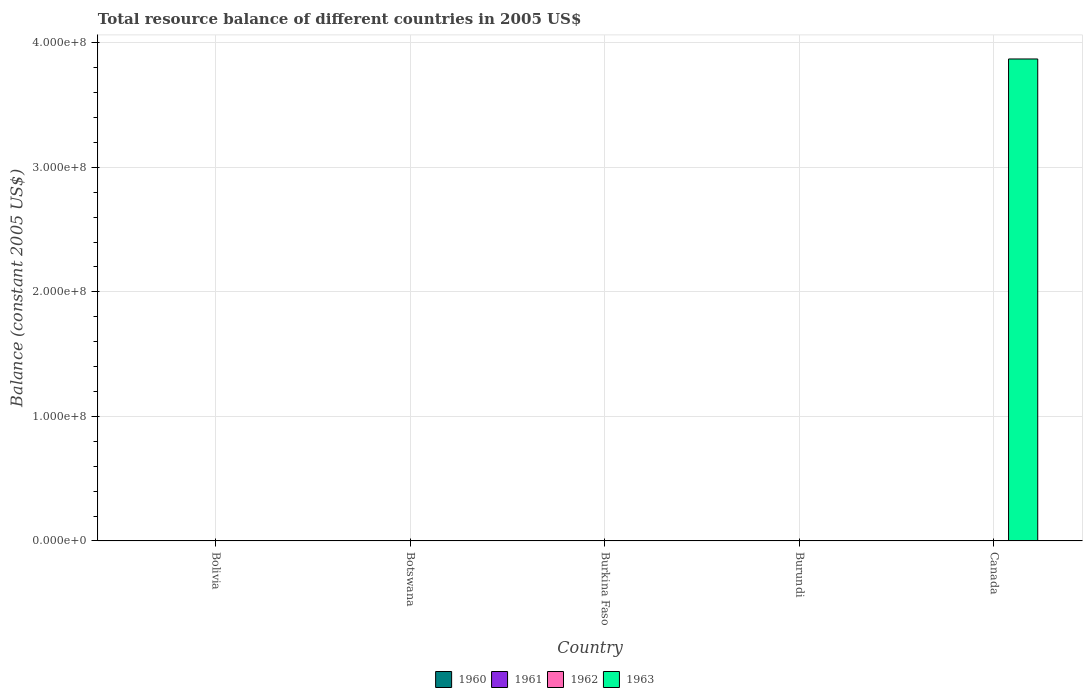Are the number of bars per tick equal to the number of legend labels?
Provide a succinct answer. No. How many bars are there on the 3rd tick from the left?
Give a very brief answer. 0. How many bars are there on the 3rd tick from the right?
Ensure brevity in your answer.  0. In how many cases, is the number of bars for a given country not equal to the number of legend labels?
Keep it short and to the point. 5. What is the total total resource balance in 1963 in the graph?
Your answer should be very brief. 3.87e+08. What is the average total resource balance in 1963 per country?
Ensure brevity in your answer.  7.74e+07. What is the difference between the highest and the lowest total resource balance in 1963?
Your response must be concise. 3.87e+08. In how many countries, is the total resource balance in 1963 greater than the average total resource balance in 1963 taken over all countries?
Offer a terse response. 1. Is it the case that in every country, the sum of the total resource balance in 1962 and total resource balance in 1961 is greater than the sum of total resource balance in 1963 and total resource balance in 1960?
Offer a terse response. No. Are all the bars in the graph horizontal?
Make the answer very short. No. What is the difference between two consecutive major ticks on the Y-axis?
Offer a very short reply. 1.00e+08. Does the graph contain grids?
Provide a succinct answer. Yes. Where does the legend appear in the graph?
Your answer should be compact. Bottom center. How are the legend labels stacked?
Your response must be concise. Horizontal. What is the title of the graph?
Offer a terse response. Total resource balance of different countries in 2005 US$. Does "1988" appear as one of the legend labels in the graph?
Keep it short and to the point. No. What is the label or title of the X-axis?
Provide a short and direct response. Country. What is the label or title of the Y-axis?
Offer a terse response. Balance (constant 2005 US$). What is the Balance (constant 2005 US$) of 1960 in Bolivia?
Provide a succinct answer. 0. What is the Balance (constant 2005 US$) in 1962 in Bolivia?
Keep it short and to the point. 0. What is the Balance (constant 2005 US$) in 1963 in Bolivia?
Give a very brief answer. 0. What is the Balance (constant 2005 US$) in 1961 in Botswana?
Your answer should be compact. 0. What is the Balance (constant 2005 US$) in 1962 in Botswana?
Your answer should be very brief. 0. What is the Balance (constant 2005 US$) in 1961 in Burundi?
Your response must be concise. 0. What is the Balance (constant 2005 US$) in 1962 in Burundi?
Offer a very short reply. 0. What is the Balance (constant 2005 US$) of 1963 in Burundi?
Make the answer very short. 0. What is the Balance (constant 2005 US$) of 1961 in Canada?
Provide a short and direct response. 0. What is the Balance (constant 2005 US$) of 1963 in Canada?
Provide a succinct answer. 3.87e+08. Across all countries, what is the maximum Balance (constant 2005 US$) in 1963?
Your answer should be very brief. 3.87e+08. What is the total Balance (constant 2005 US$) in 1961 in the graph?
Give a very brief answer. 0. What is the total Balance (constant 2005 US$) of 1963 in the graph?
Provide a succinct answer. 3.87e+08. What is the average Balance (constant 2005 US$) in 1963 per country?
Your response must be concise. 7.74e+07. What is the difference between the highest and the lowest Balance (constant 2005 US$) in 1963?
Give a very brief answer. 3.87e+08. 